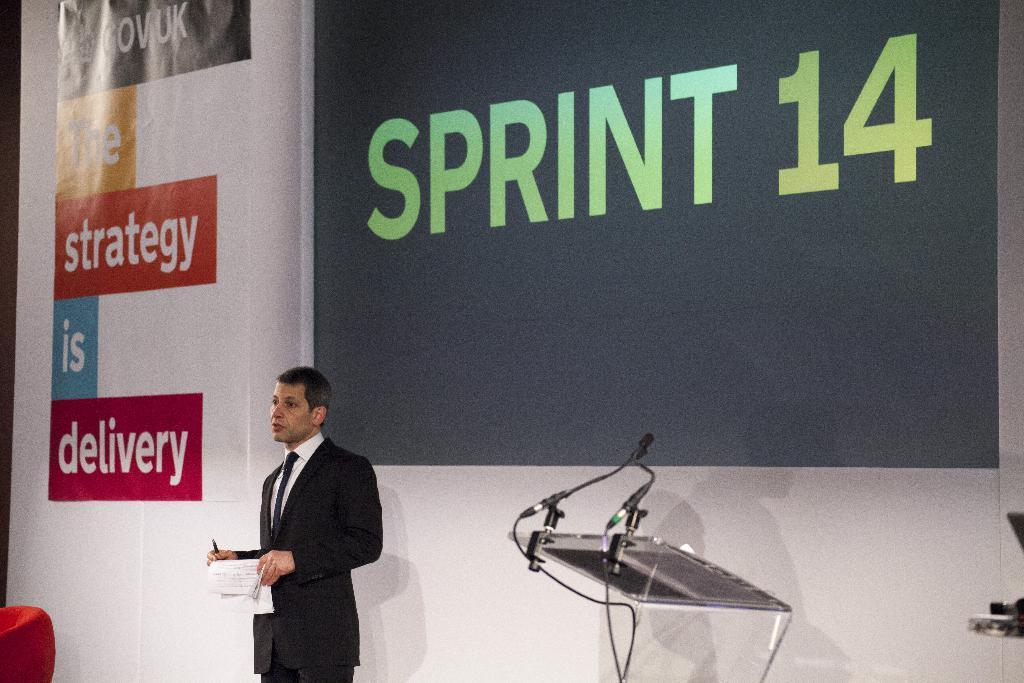Could you give a brief overview of what you see in this image? In this image there is a man in the middle who is holding the papers and a pen. Beside him there is a podium on which there are mics. In the background there is a screen. Beside the screen there is a banner. 